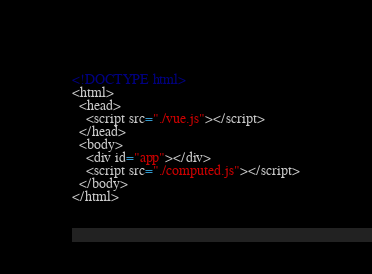<code> <loc_0><loc_0><loc_500><loc_500><_HTML_><!DOCTYPE html>
<html>
  <head>
    <script src="./vue.js"></script>
  </head>
  <body>
    <div id="app"></div>
    <script src="./computed.js"></script>
  </body>
</html></code> 